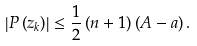Convert formula to latex. <formula><loc_0><loc_0><loc_500><loc_500>\left | P \left ( z _ { k } \right ) \right | \leq \frac { 1 } { 2 } \left ( n + 1 \right ) \left ( A - a \right ) .</formula> 